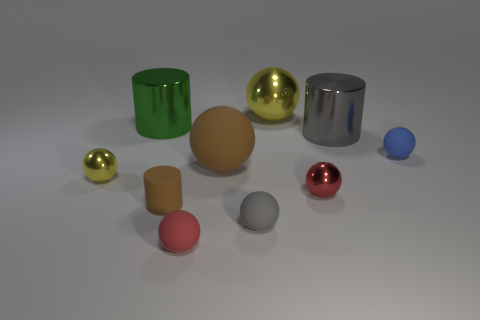Subtract 3 balls. How many balls are left? 4 Subtract all large balls. How many balls are left? 5 Subtract all red balls. How many balls are left? 5 Subtract all purple balls. Subtract all blue cylinders. How many balls are left? 7 Subtract all cylinders. How many objects are left? 7 Subtract all gray matte balls. Subtract all small brown rubber cylinders. How many objects are left? 8 Add 7 blue rubber balls. How many blue rubber balls are left? 8 Add 6 brown cubes. How many brown cubes exist? 6 Subtract 0 blue cylinders. How many objects are left? 10 